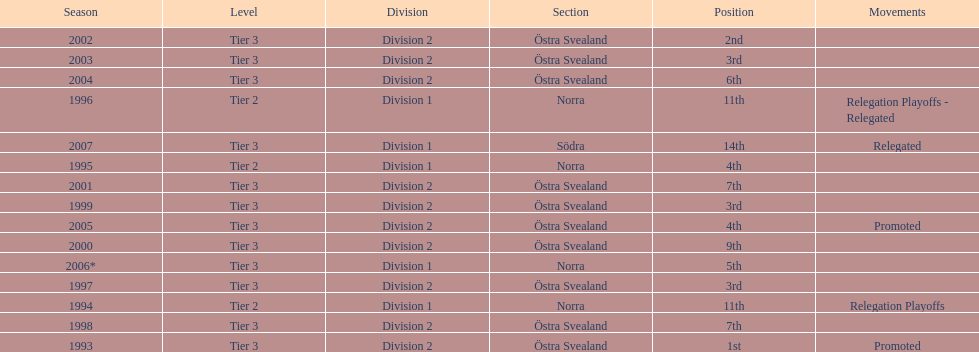In what season did visby if gute fk finish first in division 2 tier 3? 1993. 